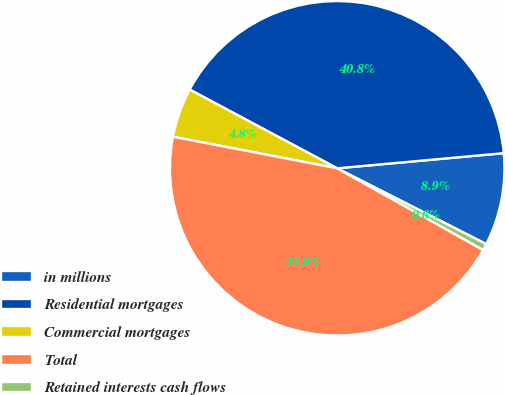Convert chart to OTSL. <chart><loc_0><loc_0><loc_500><loc_500><pie_chart><fcel>in millions<fcel>Residential mortgages<fcel>Commercial mortgages<fcel>Total<fcel>Retained interests cash flows<nl><fcel>8.93%<fcel>40.75%<fcel>4.78%<fcel>44.9%<fcel>0.63%<nl></chart> 